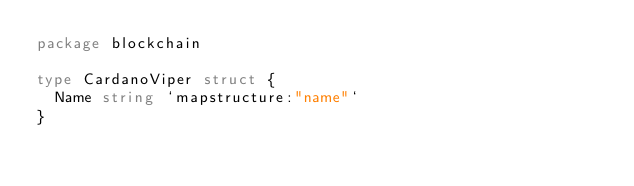Convert code to text. <code><loc_0><loc_0><loc_500><loc_500><_Go_>package blockchain

type CardanoViper struct {
	Name string `mapstructure:"name"`
}
</code> 